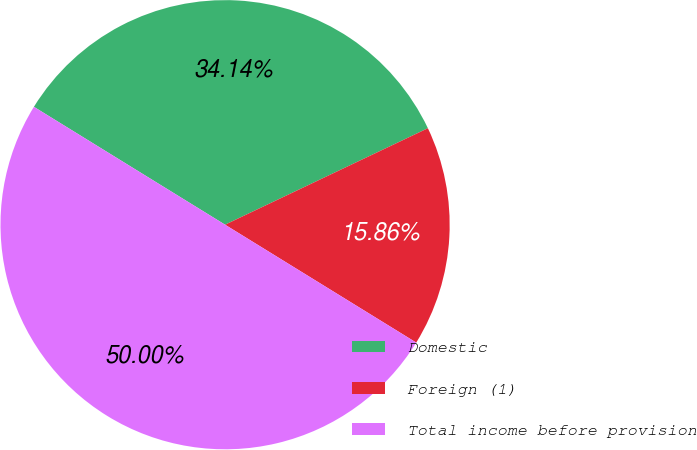Convert chart. <chart><loc_0><loc_0><loc_500><loc_500><pie_chart><fcel>Domestic<fcel>Foreign (1)<fcel>Total income before provision<nl><fcel>34.14%<fcel>15.86%<fcel>50.0%<nl></chart> 